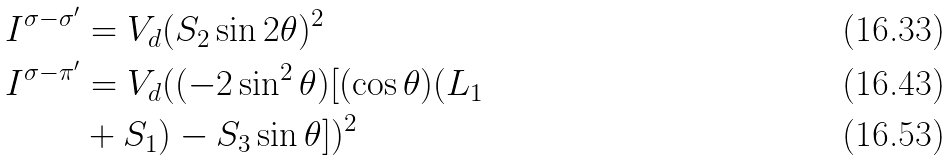Convert formula to latex. <formula><loc_0><loc_0><loc_500><loc_500>I ^ { \sigma - \sigma ^ { \prime } } & = V _ { d } ( S _ { 2 } \sin 2 \theta ) ^ { 2 } \\ I ^ { \sigma - \pi ^ { \prime } } & = V _ { d } ( ( - 2 \sin ^ { 2 } \theta ) [ ( \cos \theta ) ( L _ { 1 } \\ & + S _ { 1 } ) - S _ { 3 } \sin \theta ] ) ^ { 2 }</formula> 